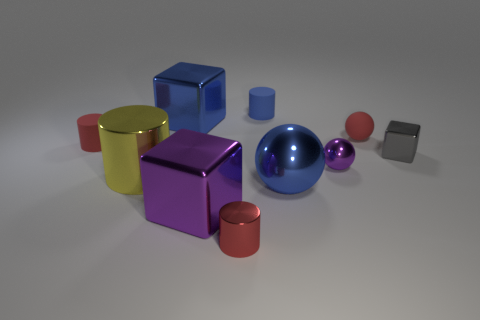Is the shape of the tiny gray shiny object the same as the tiny red metal object?
Offer a very short reply. No. What size is the shiny block that is the same color as the big sphere?
Ensure brevity in your answer.  Large. The blue metal object that is behind the red cylinder that is behind the big cylinder is what shape?
Ensure brevity in your answer.  Cube. Does the large yellow metallic object have the same shape as the tiny object on the right side of the small red ball?
Your answer should be very brief. No. What is the color of the cube that is the same size as the red sphere?
Your answer should be very brief. Gray. Are there fewer big shiny objects behind the big sphere than small matte things that are to the left of the purple metal block?
Make the answer very short. No. There is a purple metal object on the left side of the tiny matte cylinder that is right of the large blue metal thing that is behind the large yellow cylinder; what is its shape?
Ensure brevity in your answer.  Cube. There is a large shiny cube in front of the purple shiny sphere; is its color the same as the small matte object that is left of the purple metallic cube?
Give a very brief answer. No. What shape is the big metal thing that is the same color as the small metal sphere?
Provide a succinct answer. Cube. The large block behind the small cylinder left of the large yellow metal thing behind the tiny red metallic thing is what color?
Ensure brevity in your answer.  Blue. 